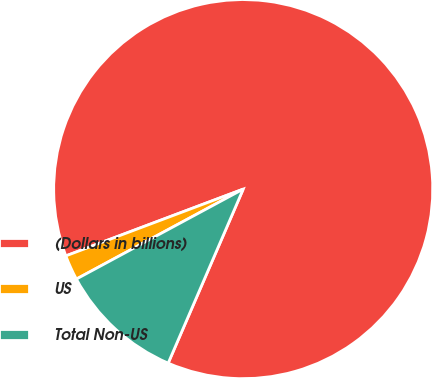Convert chart to OTSL. <chart><loc_0><loc_0><loc_500><loc_500><pie_chart><fcel>(Dollars in billions)<fcel>US<fcel>Total Non-US<nl><fcel>87.21%<fcel>2.14%<fcel>10.65%<nl></chart> 